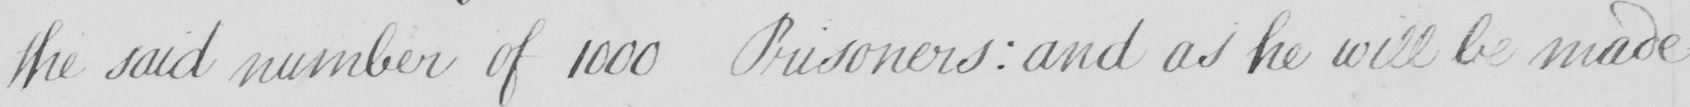What text is written in this handwritten line? the said number of 1000 Prisoners :  and as he will be made 